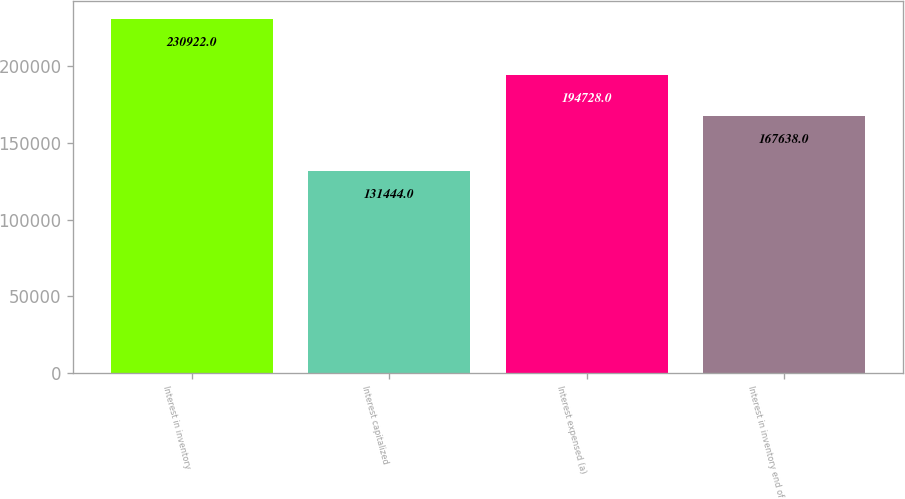Convert chart to OTSL. <chart><loc_0><loc_0><loc_500><loc_500><bar_chart><fcel>Interest in inventory<fcel>Interest capitalized<fcel>Interest expensed (a)<fcel>Interest in inventory end of<nl><fcel>230922<fcel>131444<fcel>194728<fcel>167638<nl></chart> 